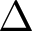<formula> <loc_0><loc_0><loc_500><loc_500>\Delta</formula> 